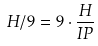Convert formula to latex. <formula><loc_0><loc_0><loc_500><loc_500>H / 9 = 9 \cdot \frac { H } { I P }</formula> 